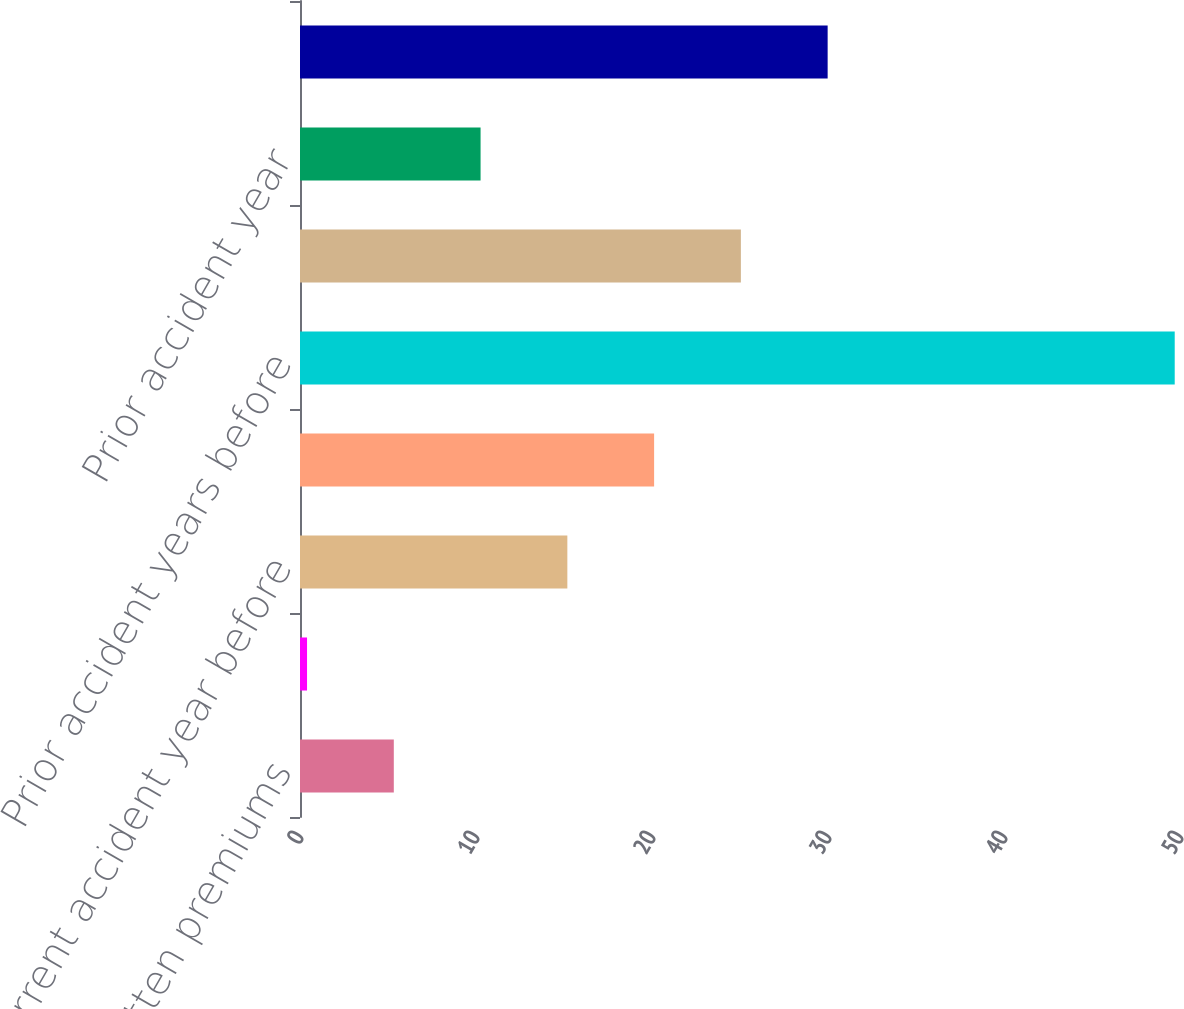<chart> <loc_0><loc_0><loc_500><loc_500><bar_chart><fcel>Written premiums<fcel>Earned premiums<fcel>Current accident year before<fcel>Current accident year<fcel>Prior accident years before<fcel>Total loss and loss expenses<fcel>Prior accident year<fcel>Total loss and loss expense<nl><fcel>5.33<fcel>0.4<fcel>15.19<fcel>20.12<fcel>49.7<fcel>25.05<fcel>10.26<fcel>29.98<nl></chart> 